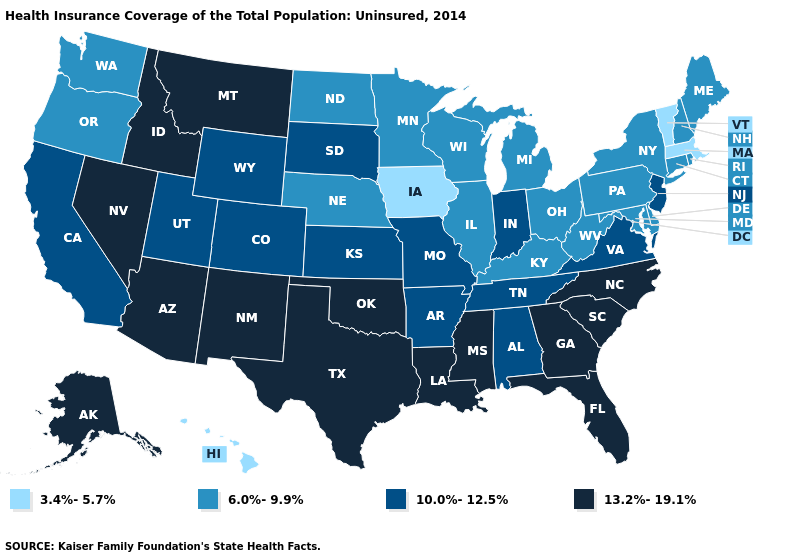What is the value of Colorado?
Short answer required. 10.0%-12.5%. Name the states that have a value in the range 13.2%-19.1%?
Keep it brief. Alaska, Arizona, Florida, Georgia, Idaho, Louisiana, Mississippi, Montana, Nevada, New Mexico, North Carolina, Oklahoma, South Carolina, Texas. Which states have the lowest value in the MidWest?
Quick response, please. Iowa. What is the value of Virginia?
Answer briefly. 10.0%-12.5%. What is the value of Arkansas?
Keep it brief. 10.0%-12.5%. Among the states that border Minnesota , which have the lowest value?
Concise answer only. Iowa. Is the legend a continuous bar?
Quick response, please. No. Does New Hampshire have the lowest value in the Northeast?
Concise answer only. No. Does Florida have a higher value than New Mexico?
Short answer required. No. What is the value of Louisiana?
Be succinct. 13.2%-19.1%. Name the states that have a value in the range 10.0%-12.5%?
Short answer required. Alabama, Arkansas, California, Colorado, Indiana, Kansas, Missouri, New Jersey, South Dakota, Tennessee, Utah, Virginia, Wyoming. Which states have the lowest value in the USA?
Concise answer only. Hawaii, Iowa, Massachusetts, Vermont. Is the legend a continuous bar?
Be succinct. No. Name the states that have a value in the range 6.0%-9.9%?
Quick response, please. Connecticut, Delaware, Illinois, Kentucky, Maine, Maryland, Michigan, Minnesota, Nebraska, New Hampshire, New York, North Dakota, Ohio, Oregon, Pennsylvania, Rhode Island, Washington, West Virginia, Wisconsin. Among the states that border Kentucky , which have the lowest value?
Give a very brief answer. Illinois, Ohio, West Virginia. 